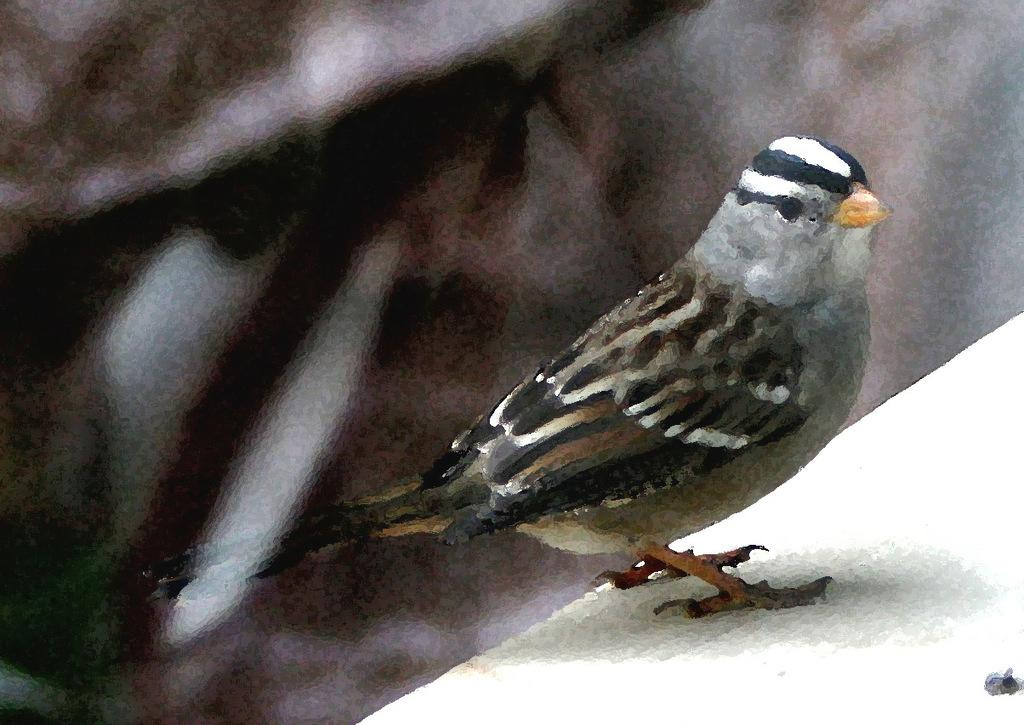What type of animal is in the image? There is a bird in the image. What colors can be seen on the bird? The bird has white, black, and brown colors. Where is the bird located in the image? The bird is on a white surface. What colors are present in the background of the image? The background of the image is white and brown. Who created the bead that the bird is holding in the image? There is no bead present in the image, and therefore no one created it. What type of dinner is being served in the image? There is no dinner present in the image; it features a bird on a white surface. 